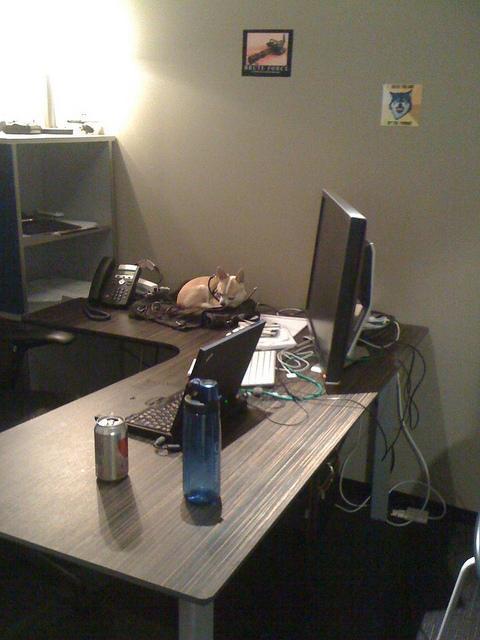How many computers are shown?
Give a very brief answer. 2. How many laptops are there?
Give a very brief answer. 1. How many tvs are visible?
Give a very brief answer. 2. 